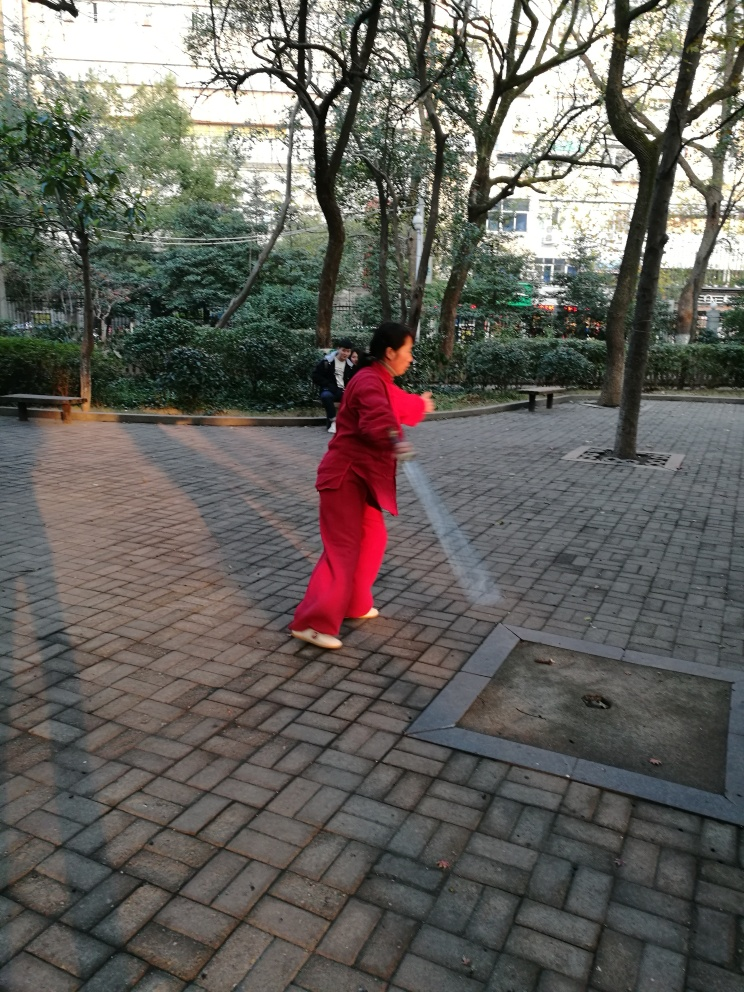What activity is the person in the image performing, and does it seem like a common practice in this setting? The person appears to be engaged in a form of exercise or perhaps a martial art, indicated by their focused stance and extended arms. Given the park-like setting with ample space and trees, it's plausible that this is a common area for individuals to practice such activities, especially in cultures where morning or evening exercises in public spaces are a routine part of daily life. Does this activity have any cultural significance? Yes, activities like this are often steeped in cultural traditions, particularly in places such as China where Tai Chi and other forms of martial arts are commonly practiced in public parks. These exercises are not only a way to keep physically fit but also to maintain balance, focus, and peace of mind. 